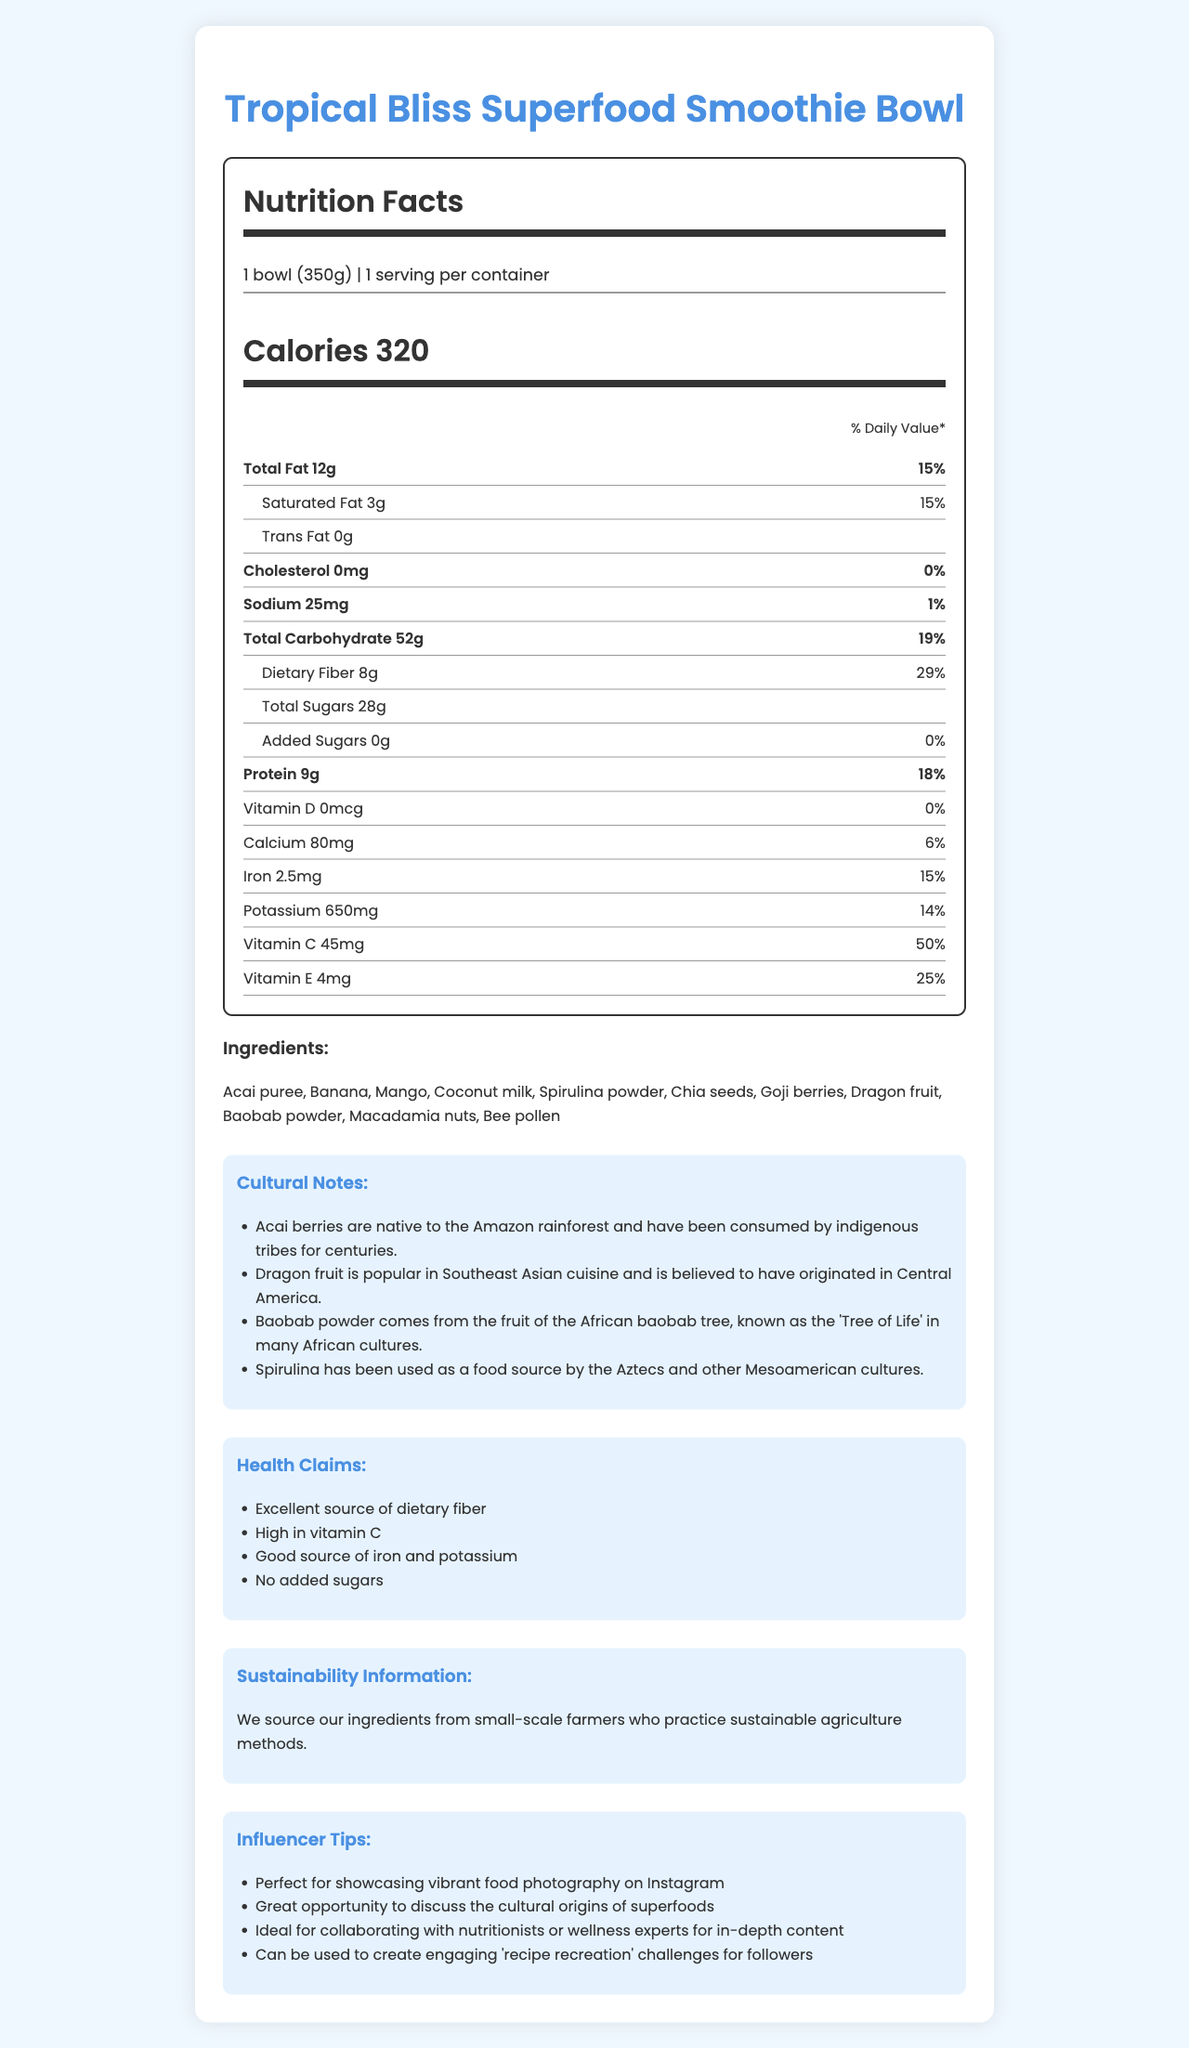what is the name of the product? The product name is clearly stated at the top of the document.
Answer: Tropical Bliss Superfood Smoothie Bowl what is the serving size? The serving size is shown in the serving information section of the nutrition label.
Answer: 1 bowl (350g) how many calories are in one serving? The document states that there are 320 calories per serving.
Answer: 320 what percentage of daily value for dietary fiber does this product provide? This information is located in the nutrition label under the dietary fiber entry.
Answer: 29% how much protein does one bowl contain? The protein content can be found in the nutrition label section.
Answer: 9 grams which nutrient has the highest daily value percentage? A. Saturated Fat B. Iron C. Vitamin C D. Calcium Vitamin C has the highest daily value percentage at 50%, as shown in the nutritional information.
Answer: C what are the ingredients that contain allergens? A. Acai puree B. Banana C. Macadamia nuts D. Goji berries The document lists allergens separately and mentions tree nuts (Macadamia).
Answer: C is there any added sugar in this product? The nutritional label shows 0 grams of added sugars.
Answer: No does this product contain trans fat? The document states that the trans fat amount is 0 grams.
Answer: No what cultural notes are mentioned about Acai berries? The cultural notes section provides this information regarding Acai berries.
Answer: Acai berries are native to the Amazon rainforest and have been consumed by indigenous tribes for centuries. is this product suitable for vegans? The document does not specify whether it is suitable for vegans, although it lists 'bee pollen', which may be avoided by vegans.
Answer: Not enough information what claim does this product make about its sustainability practices? This information is found in the sustainability info section.
Answer: We source our ingredients from small-scale farmers who practice sustainable agriculture methods. summarize the main idea of this document. The document details various aspects of the product, including nutritional breakdown, cultural history of ingredients, health benefits, and suggestions for social media influencers.
Answer: The document provides comprehensive nutritional information, cultural contexts, health claims, sustainability practices, and influencer tips about the Tropical Bliss Superfood Smoothie Bowl. what nutrients are labeled as excellent sources? A. Potassium B. Vitamin C C. Protein D. Dietary Fiber Dietary Fiber is labeled as an excellent source in the health claims section.
Answer: D 